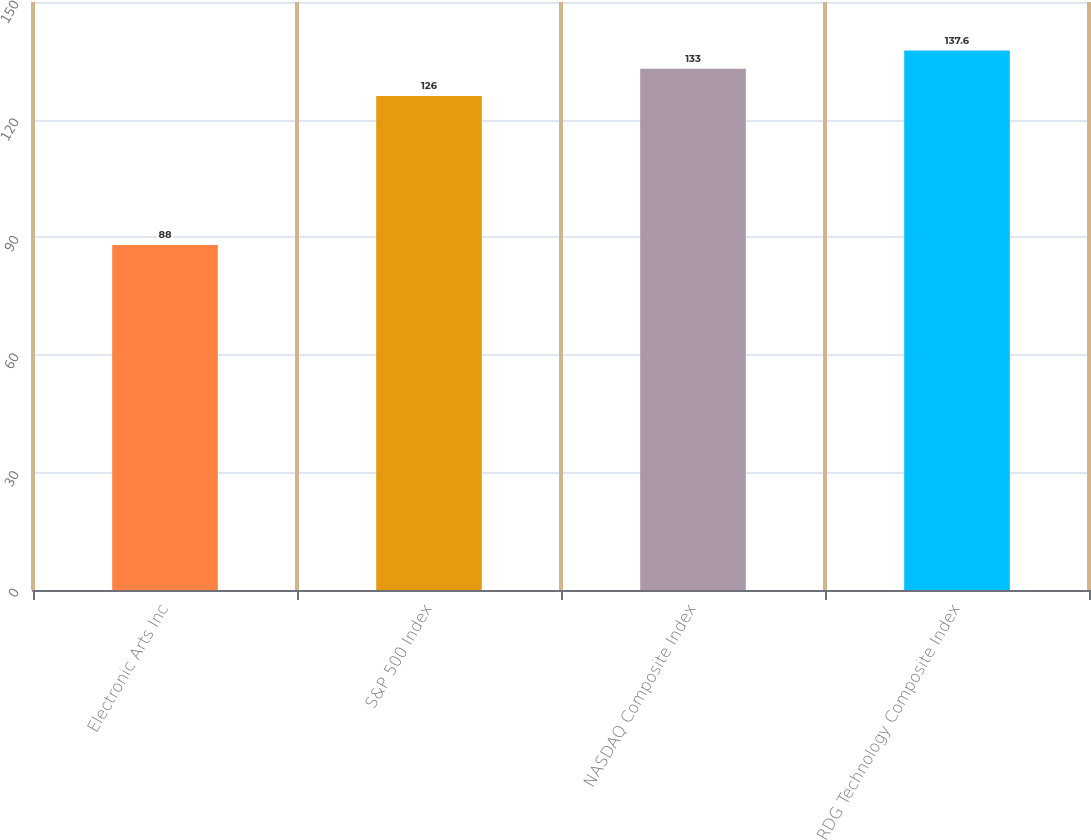Convert chart. <chart><loc_0><loc_0><loc_500><loc_500><bar_chart><fcel>Electronic Arts Inc<fcel>S&P 500 Index<fcel>NASDAQ Composite Index<fcel>RDG Technology Composite Index<nl><fcel>88<fcel>126<fcel>133<fcel>137.6<nl></chart> 